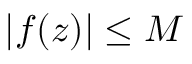Convert formula to latex. <formula><loc_0><loc_0><loc_500><loc_500>| f ( z ) | \leq M</formula> 